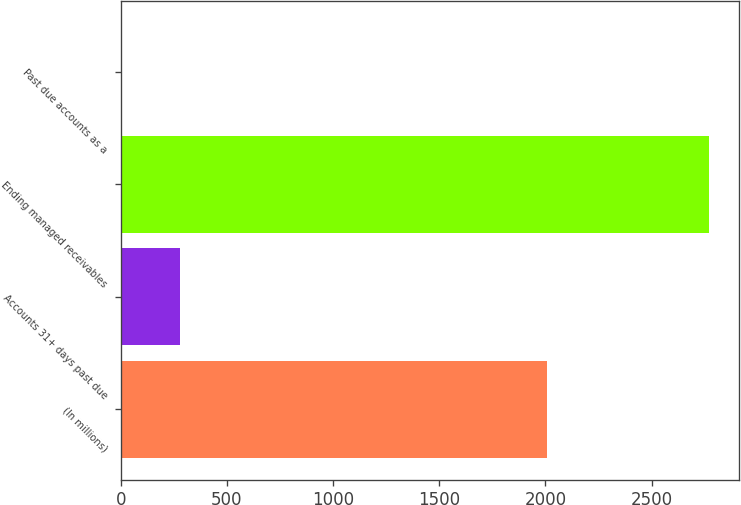Convert chart. <chart><loc_0><loc_0><loc_500><loc_500><bar_chart><fcel>(In millions)<fcel>Accounts 31+ days past due<fcel>Ending managed receivables<fcel>Past due accounts as a<nl><fcel>2006<fcel>278.47<fcel>2772.5<fcel>1.35<nl></chart> 